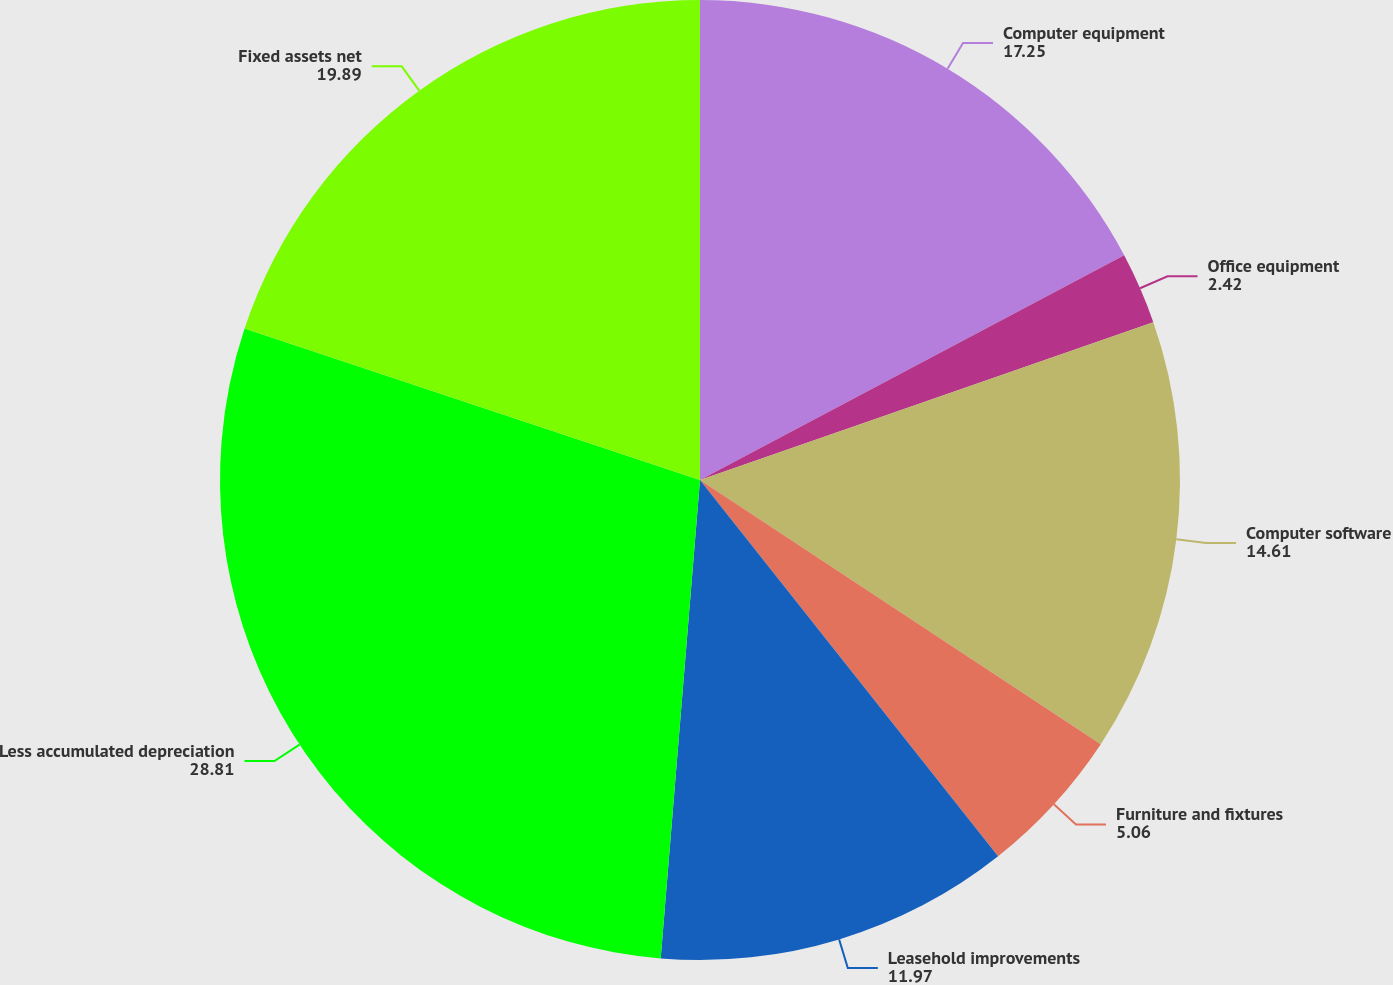Convert chart. <chart><loc_0><loc_0><loc_500><loc_500><pie_chart><fcel>Computer equipment<fcel>Office equipment<fcel>Computer software<fcel>Furniture and fixtures<fcel>Leasehold improvements<fcel>Less accumulated depreciation<fcel>Fixed assets net<nl><fcel>17.25%<fcel>2.42%<fcel>14.61%<fcel>5.06%<fcel>11.97%<fcel>28.81%<fcel>19.89%<nl></chart> 